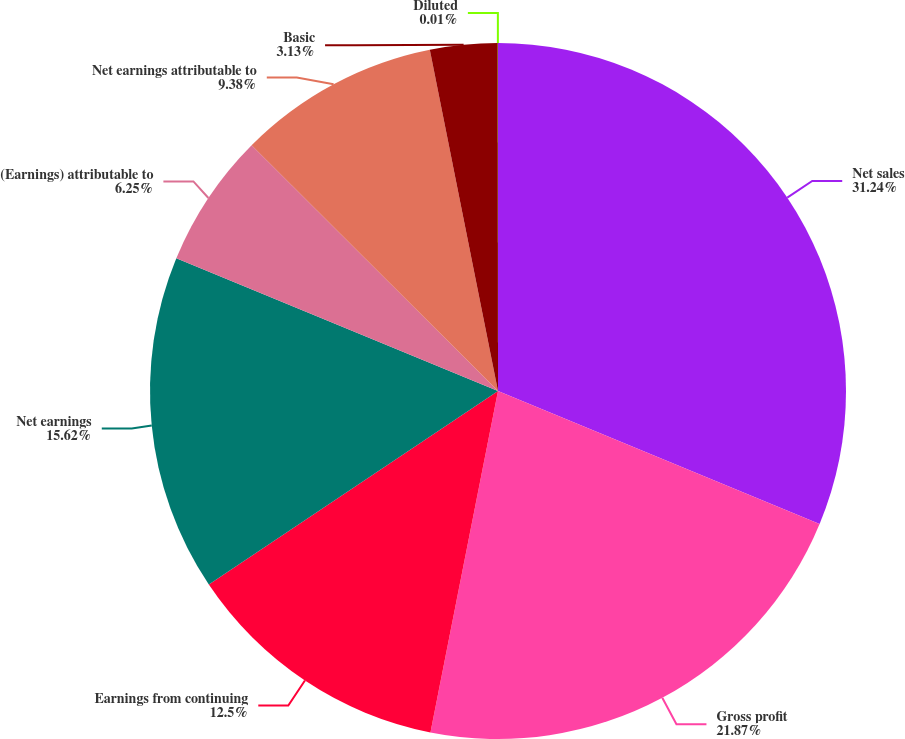<chart> <loc_0><loc_0><loc_500><loc_500><pie_chart><fcel>Net sales<fcel>Gross profit<fcel>Earnings from continuing<fcel>Net earnings<fcel>(Earnings) attributable to<fcel>Net earnings attributable to<fcel>Basic<fcel>Diluted<nl><fcel>31.24%<fcel>21.87%<fcel>12.5%<fcel>15.62%<fcel>6.25%<fcel>9.38%<fcel>3.13%<fcel>0.01%<nl></chart> 